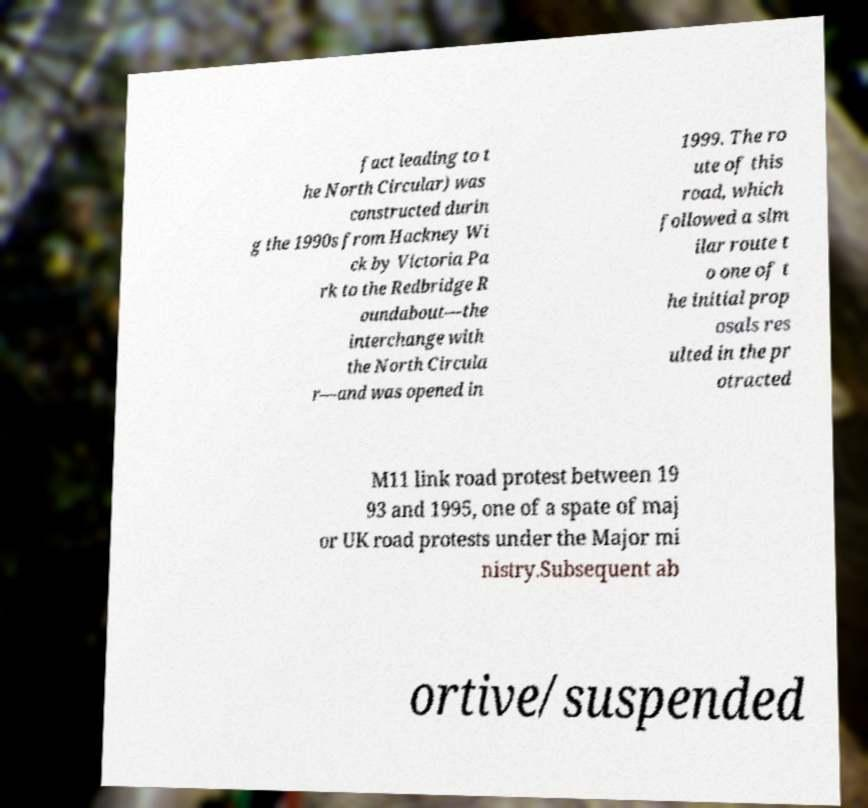Could you extract and type out the text from this image? fact leading to t he North Circular) was constructed durin g the 1990s from Hackney Wi ck by Victoria Pa rk to the Redbridge R oundabout—the interchange with the North Circula r—and was opened in 1999. The ro ute of this road, which followed a sim ilar route t o one of t he initial prop osals res ulted in the pr otracted M11 link road protest between 19 93 and 1995, one of a spate of maj or UK road protests under the Major mi nistry.Subsequent ab ortive/suspended 